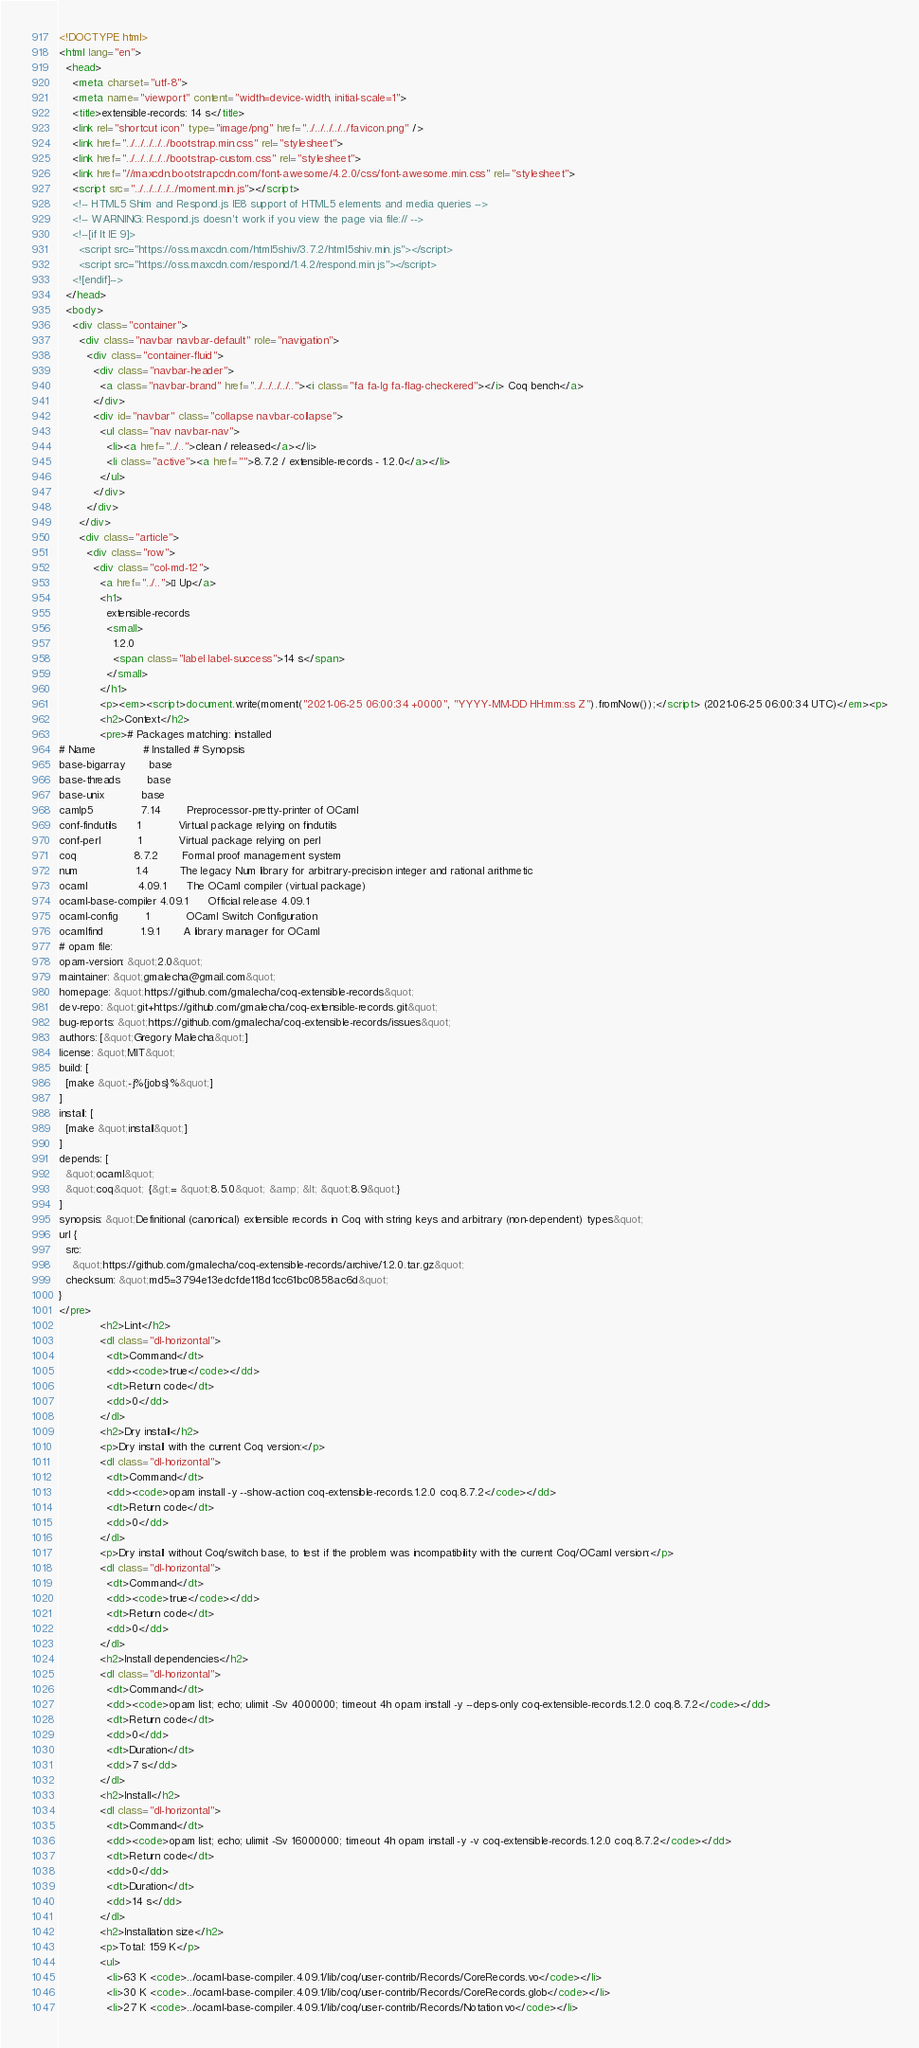Convert code to text. <code><loc_0><loc_0><loc_500><loc_500><_HTML_><!DOCTYPE html>
<html lang="en">
  <head>
    <meta charset="utf-8">
    <meta name="viewport" content="width=device-width, initial-scale=1">
    <title>extensible-records: 14 s</title>
    <link rel="shortcut icon" type="image/png" href="../../../../../favicon.png" />
    <link href="../../../../../bootstrap.min.css" rel="stylesheet">
    <link href="../../../../../bootstrap-custom.css" rel="stylesheet">
    <link href="//maxcdn.bootstrapcdn.com/font-awesome/4.2.0/css/font-awesome.min.css" rel="stylesheet">
    <script src="../../../../../moment.min.js"></script>
    <!-- HTML5 Shim and Respond.js IE8 support of HTML5 elements and media queries -->
    <!-- WARNING: Respond.js doesn't work if you view the page via file:// -->
    <!--[if lt IE 9]>
      <script src="https://oss.maxcdn.com/html5shiv/3.7.2/html5shiv.min.js"></script>
      <script src="https://oss.maxcdn.com/respond/1.4.2/respond.min.js"></script>
    <![endif]-->
  </head>
  <body>
    <div class="container">
      <div class="navbar navbar-default" role="navigation">
        <div class="container-fluid">
          <div class="navbar-header">
            <a class="navbar-brand" href="../../../../.."><i class="fa fa-lg fa-flag-checkered"></i> Coq bench</a>
          </div>
          <div id="navbar" class="collapse navbar-collapse">
            <ul class="nav navbar-nav">
              <li><a href="../..">clean / released</a></li>
              <li class="active"><a href="">8.7.2 / extensible-records - 1.2.0</a></li>
            </ul>
          </div>
        </div>
      </div>
      <div class="article">
        <div class="row">
          <div class="col-md-12">
            <a href="../..">« Up</a>
            <h1>
              extensible-records
              <small>
                1.2.0
                <span class="label label-success">14 s</span>
              </small>
            </h1>
            <p><em><script>document.write(moment("2021-06-25 06:00:34 +0000", "YYYY-MM-DD HH:mm:ss Z").fromNow());</script> (2021-06-25 06:00:34 UTC)</em><p>
            <h2>Context</h2>
            <pre># Packages matching: installed
# Name              # Installed # Synopsis
base-bigarray       base
base-threads        base
base-unix           base
camlp5              7.14        Preprocessor-pretty-printer of OCaml
conf-findutils      1           Virtual package relying on findutils
conf-perl           1           Virtual package relying on perl
coq                 8.7.2       Formal proof management system
num                 1.4         The legacy Num library for arbitrary-precision integer and rational arithmetic
ocaml               4.09.1      The OCaml compiler (virtual package)
ocaml-base-compiler 4.09.1      Official release 4.09.1
ocaml-config        1           OCaml Switch Configuration
ocamlfind           1.9.1       A library manager for OCaml
# opam file:
opam-version: &quot;2.0&quot;
maintainer: &quot;gmalecha@gmail.com&quot;
homepage: &quot;https://github.com/gmalecha/coq-extensible-records&quot;
dev-repo: &quot;git+https://github.com/gmalecha/coq-extensible-records.git&quot;
bug-reports: &quot;https://github.com/gmalecha/coq-extensible-records/issues&quot;
authors: [&quot;Gregory Malecha&quot;]
license: &quot;MIT&quot;
build: [
  [make &quot;-j%{jobs}%&quot;]
]
install: [
  [make &quot;install&quot;]
]
depends: [
  &quot;ocaml&quot;
  &quot;coq&quot; {&gt;= &quot;8.5.0&quot; &amp; &lt; &quot;8.9&quot;}
]
synopsis: &quot;Definitional (canonical) extensible records in Coq with string keys and arbitrary (non-dependent) types&quot;
url {
  src:
    &quot;https://github.com/gmalecha/coq-extensible-records/archive/1.2.0.tar.gz&quot;
  checksum: &quot;md5=3794e13edcfde118d1cc61bc0858ac6d&quot;
}
</pre>
            <h2>Lint</h2>
            <dl class="dl-horizontal">
              <dt>Command</dt>
              <dd><code>true</code></dd>
              <dt>Return code</dt>
              <dd>0</dd>
            </dl>
            <h2>Dry install</h2>
            <p>Dry install with the current Coq version:</p>
            <dl class="dl-horizontal">
              <dt>Command</dt>
              <dd><code>opam install -y --show-action coq-extensible-records.1.2.0 coq.8.7.2</code></dd>
              <dt>Return code</dt>
              <dd>0</dd>
            </dl>
            <p>Dry install without Coq/switch base, to test if the problem was incompatibility with the current Coq/OCaml version:</p>
            <dl class="dl-horizontal">
              <dt>Command</dt>
              <dd><code>true</code></dd>
              <dt>Return code</dt>
              <dd>0</dd>
            </dl>
            <h2>Install dependencies</h2>
            <dl class="dl-horizontal">
              <dt>Command</dt>
              <dd><code>opam list; echo; ulimit -Sv 4000000; timeout 4h opam install -y --deps-only coq-extensible-records.1.2.0 coq.8.7.2</code></dd>
              <dt>Return code</dt>
              <dd>0</dd>
              <dt>Duration</dt>
              <dd>7 s</dd>
            </dl>
            <h2>Install</h2>
            <dl class="dl-horizontal">
              <dt>Command</dt>
              <dd><code>opam list; echo; ulimit -Sv 16000000; timeout 4h opam install -y -v coq-extensible-records.1.2.0 coq.8.7.2</code></dd>
              <dt>Return code</dt>
              <dd>0</dd>
              <dt>Duration</dt>
              <dd>14 s</dd>
            </dl>
            <h2>Installation size</h2>
            <p>Total: 159 K</p>
            <ul>
              <li>63 K <code>../ocaml-base-compiler.4.09.1/lib/coq/user-contrib/Records/CoreRecords.vo</code></li>
              <li>30 K <code>../ocaml-base-compiler.4.09.1/lib/coq/user-contrib/Records/CoreRecords.glob</code></li>
              <li>27 K <code>../ocaml-base-compiler.4.09.1/lib/coq/user-contrib/Records/Notation.vo</code></li></code> 